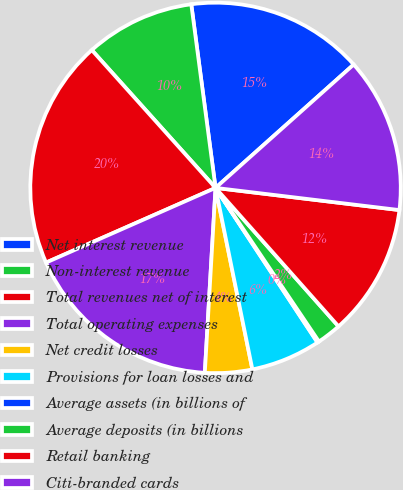Convert chart. <chart><loc_0><loc_0><loc_500><loc_500><pie_chart><fcel>Net interest revenue<fcel>Non-interest revenue<fcel>Total revenues net of interest<fcel>Total operating expenses<fcel>Net credit losses<fcel>Provisions for loan losses and<fcel>Average assets (in billions of<fcel>Average deposits (in billions<fcel>Retail banking<fcel>Citi-branded cards<nl><fcel>15.49%<fcel>9.55%<fcel>19.96%<fcel>17.47%<fcel>4.11%<fcel>6.09%<fcel>0.15%<fcel>2.13%<fcel>11.53%<fcel>13.51%<nl></chart> 